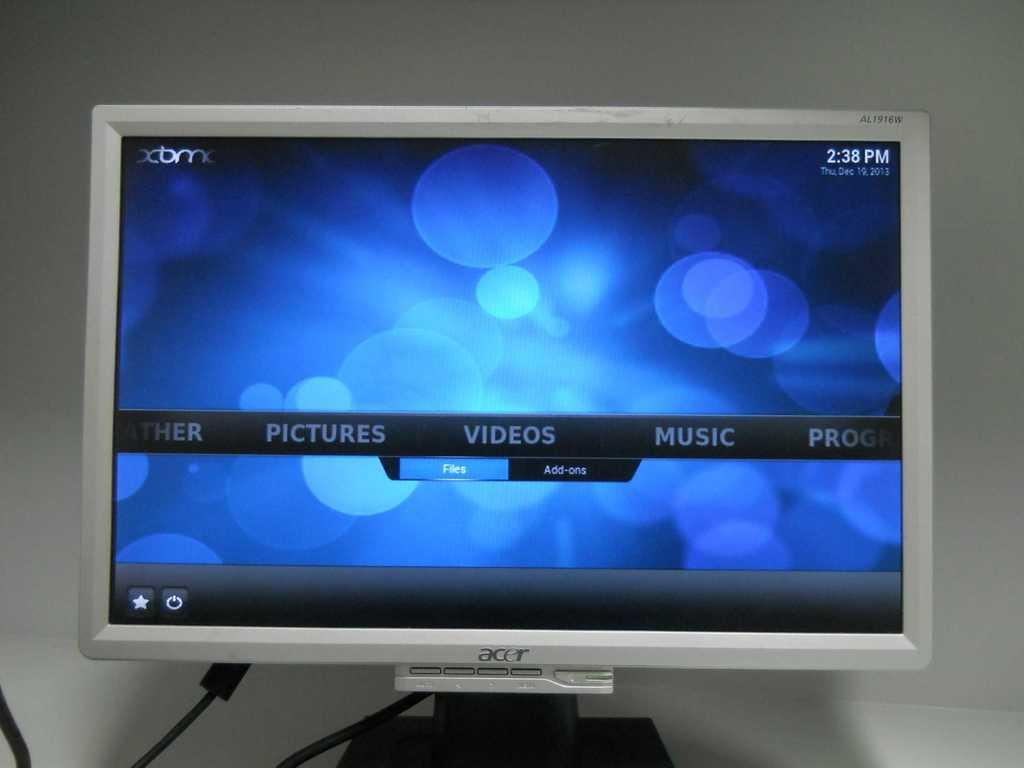<image>
Summarize the visual content of the image. A silver computer monitor from the company Acer 